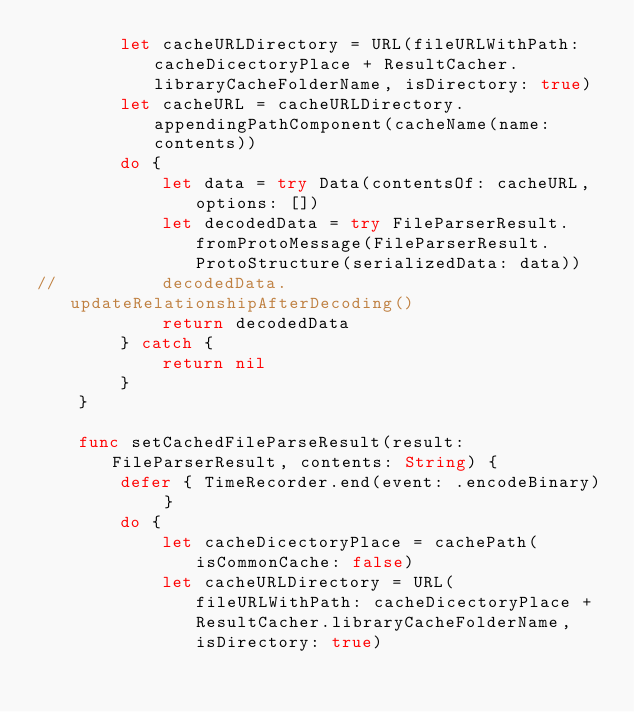Convert code to text. <code><loc_0><loc_0><loc_500><loc_500><_Swift_>		let cacheURLDirectory = URL(fileURLWithPath: cacheDicectoryPlace + ResultCacher.libraryCacheFolderName, isDirectory: true)
		let cacheURL = cacheURLDirectory.appendingPathComponent(cacheName(name: contents))
		do {
			let data = try Data(contentsOf: cacheURL, options: [])
			let decodedData = try FileParserResult.fromProtoMessage(FileParserResult.ProtoStructure(serializedData: data))
//			decodedData.updateRelationshipAfterDecoding()
			return decodedData
		} catch {
			return nil
		}
	}
	
	func setCachedFileParseResult(result: FileParserResult, contents: String) {
		defer { TimeRecorder.end(event: .encodeBinary) }
		do {
			let cacheDicectoryPlace = cachePath(isCommonCache: false)
			let cacheURLDirectory = URL(fileURLWithPath: cacheDicectoryPlace + ResultCacher.libraryCacheFolderName, isDirectory: true)</code> 